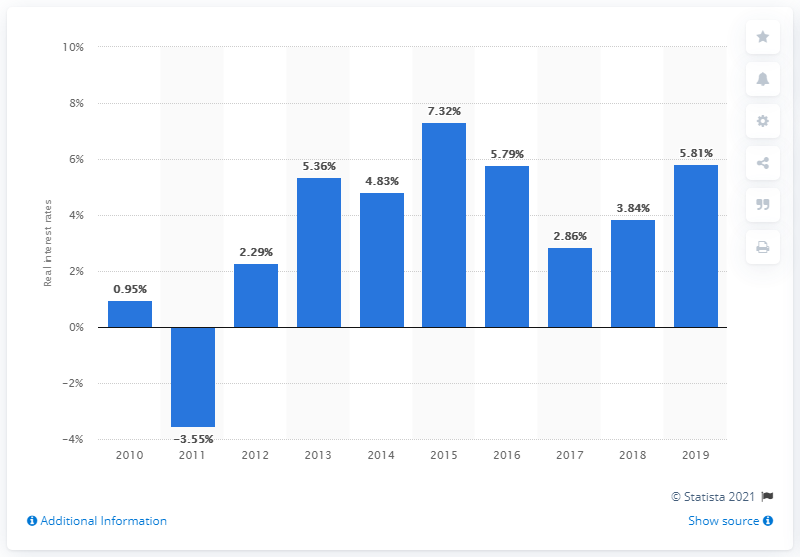Highlight a few significant elements in this photo. The real interest rate in Vietnam in 2019 was 5.81%. 